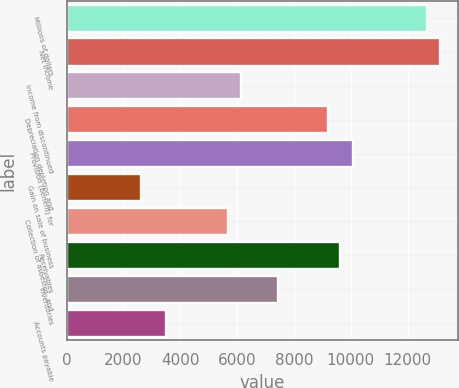Convert chart. <chart><loc_0><loc_0><loc_500><loc_500><bar_chart><fcel>Millions of dollars<fcel>Net income<fcel>Income from discontinued<fcel>Depreciation depletion and<fcel>Provision (benefit) for<fcel>Gain on sale of business<fcel>Collection of asbestos- and<fcel>Receivables<fcel>Inventories<fcel>Accounts payable<nl><fcel>12689.6<fcel>13127<fcel>6128.6<fcel>9190.4<fcel>10065.2<fcel>2629.4<fcel>5691.2<fcel>9627.8<fcel>7440.8<fcel>3504.2<nl></chart> 